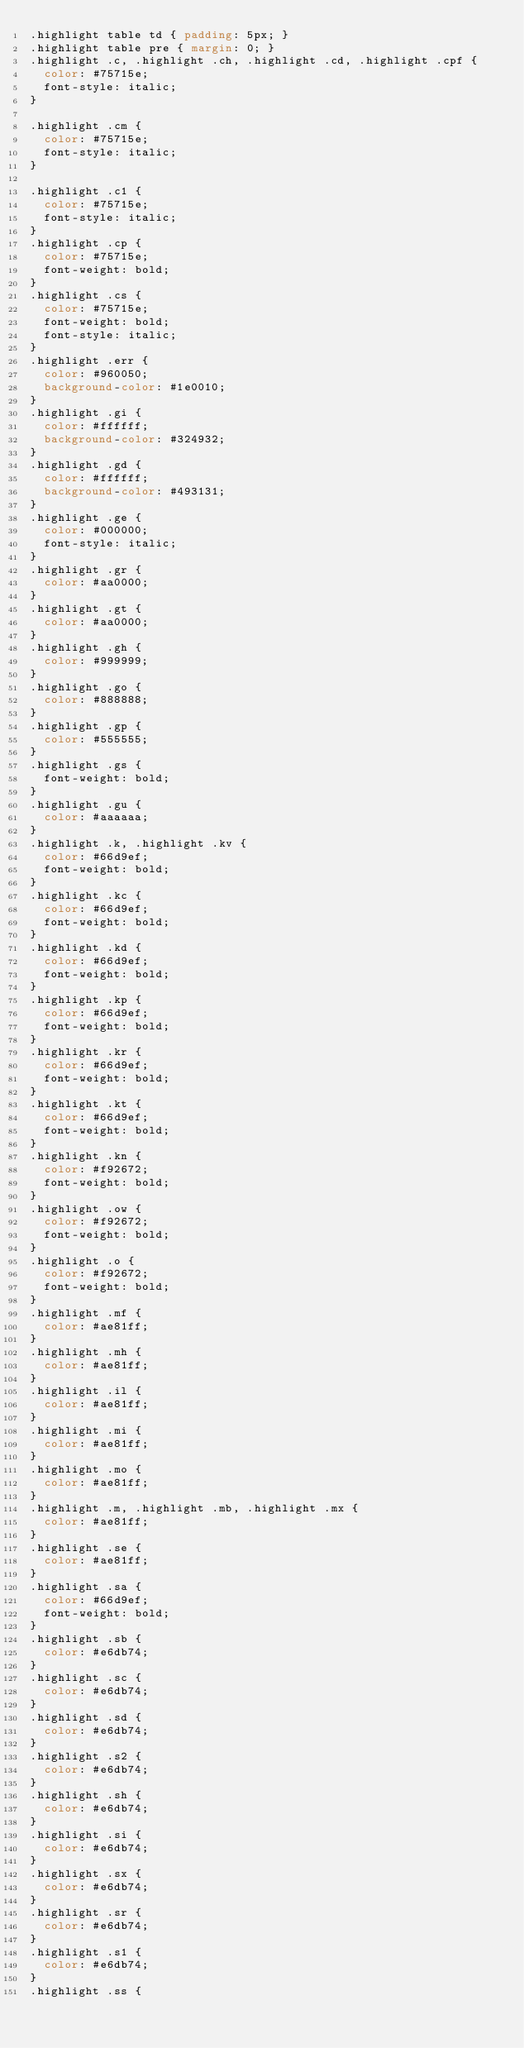Convert code to text. <code><loc_0><loc_0><loc_500><loc_500><_CSS_>.highlight table td { padding: 5px; }
.highlight table pre { margin: 0; }
.highlight .c, .highlight .ch, .highlight .cd, .highlight .cpf {
  color: #75715e;
  font-style: italic;
}

.highlight .cm {
  color: #75715e;
  font-style: italic;
}

.highlight .c1 {
  color: #75715e;
  font-style: italic;
}
.highlight .cp {
  color: #75715e;
  font-weight: bold;
}
.highlight .cs {
  color: #75715e;
  font-weight: bold;
  font-style: italic;
}
.highlight .err {
  color: #960050;
  background-color: #1e0010;
}
.highlight .gi {
  color: #ffffff;
  background-color: #324932;
}
.highlight .gd {
  color: #ffffff;
  background-color: #493131;
}
.highlight .ge {
  color: #000000;
  font-style: italic;
}
.highlight .gr {
  color: #aa0000;
}
.highlight .gt {
  color: #aa0000;
}
.highlight .gh {
  color: #999999;
}
.highlight .go {
  color: #888888;
}
.highlight .gp {
  color: #555555;
}
.highlight .gs {
  font-weight: bold;
}
.highlight .gu {
  color: #aaaaaa;
}
.highlight .k, .highlight .kv {
  color: #66d9ef;
  font-weight: bold;
}
.highlight .kc {
  color: #66d9ef;
  font-weight: bold;
}
.highlight .kd {
  color: #66d9ef;
  font-weight: bold;
}
.highlight .kp {
  color: #66d9ef;
  font-weight: bold;
}
.highlight .kr {
  color: #66d9ef;
  font-weight: bold;
}
.highlight .kt {
  color: #66d9ef;
  font-weight: bold;
}
.highlight .kn {
  color: #f92672;
  font-weight: bold;
}
.highlight .ow {
  color: #f92672;
  font-weight: bold;
}
.highlight .o {
  color: #f92672;
  font-weight: bold;
}
.highlight .mf {
  color: #ae81ff;
}
.highlight .mh {
  color: #ae81ff;
}
.highlight .il {
  color: #ae81ff;
}
.highlight .mi {
  color: #ae81ff;
}
.highlight .mo {
  color: #ae81ff;
}
.highlight .m, .highlight .mb, .highlight .mx {
  color: #ae81ff;
}
.highlight .se {
  color: #ae81ff;
}
.highlight .sa {
  color: #66d9ef;
  font-weight: bold;
}
.highlight .sb {
  color: #e6db74;
}
.highlight .sc {
  color: #e6db74;
}
.highlight .sd {
  color: #e6db74;
}
.highlight .s2 {
  color: #e6db74;
}
.highlight .sh {
  color: #e6db74;
}
.highlight .si {
  color: #e6db74;
}
.highlight .sx {
  color: #e6db74;
}
.highlight .sr {
  color: #e6db74;
}
.highlight .s1 {
  color: #e6db74;
}
.highlight .ss {</code> 